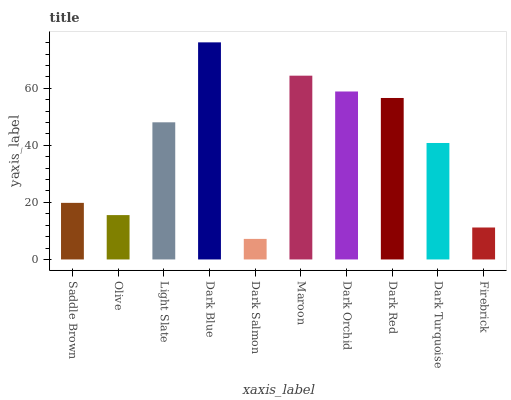Is Dark Salmon the minimum?
Answer yes or no. Yes. Is Dark Blue the maximum?
Answer yes or no. Yes. Is Olive the minimum?
Answer yes or no. No. Is Olive the maximum?
Answer yes or no. No. Is Saddle Brown greater than Olive?
Answer yes or no. Yes. Is Olive less than Saddle Brown?
Answer yes or no. Yes. Is Olive greater than Saddle Brown?
Answer yes or no. No. Is Saddle Brown less than Olive?
Answer yes or no. No. Is Light Slate the high median?
Answer yes or no. Yes. Is Dark Turquoise the low median?
Answer yes or no. Yes. Is Maroon the high median?
Answer yes or no. No. Is Light Slate the low median?
Answer yes or no. No. 